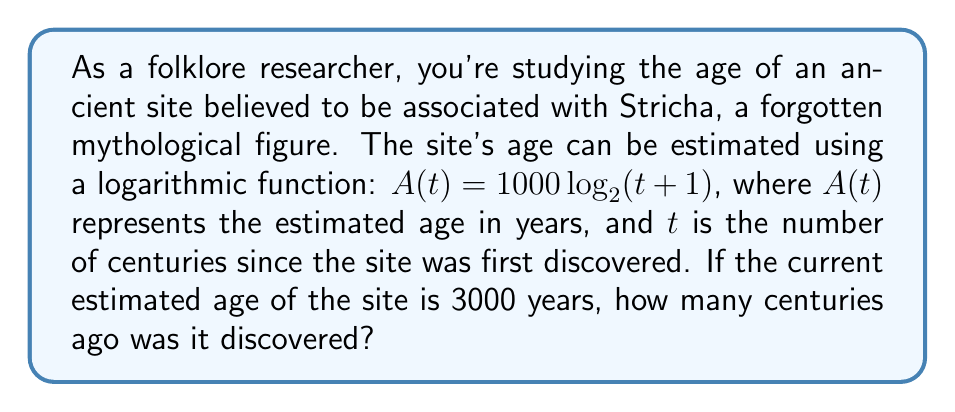Show me your answer to this math problem. To solve this problem, we need to use the given logarithmic function and work backwards to find $t$. Let's approach this step-by-step:

1) We're given the function: $A(t) = 1000 \log_{2}(t+1)$

2) We know that the current estimated age is 3000 years, so:
   $3000 = 1000 \log_{2}(t+1)$

3) Divide both sides by 1000:
   $3 = \log_{2}(t+1)$

4) To solve for $t$, we need to apply the inverse function (exponential) to both sides:
   $2^3 = t+1$

5) Simplify the left side:
   $8 = t+1$

6) Subtract 1 from both sides:
   $7 = t$

Therefore, the site was discovered 7 centuries ago.
Answer: 7 centuries 